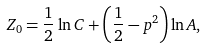Convert formula to latex. <formula><loc_0><loc_0><loc_500><loc_500>Z _ { 0 } = \frac { 1 } { 2 } \ln { C } + \left ( \frac { 1 } { 2 } - p ^ { 2 } \right ) \ln { A } ,</formula> 